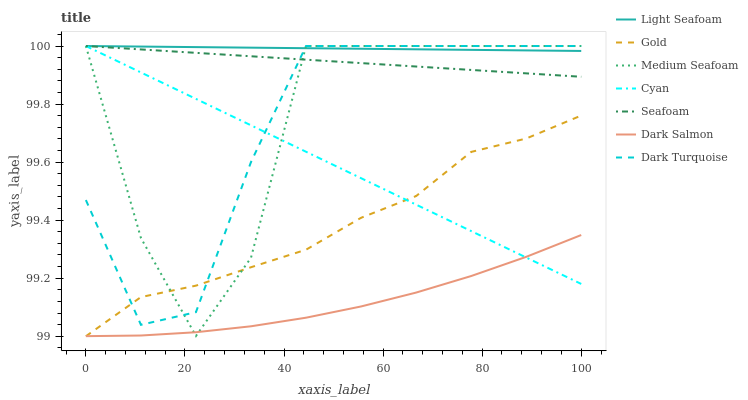Does Dark Salmon have the minimum area under the curve?
Answer yes or no. Yes. Does Light Seafoam have the maximum area under the curve?
Answer yes or no. Yes. Does Dark Turquoise have the minimum area under the curve?
Answer yes or no. No. Does Dark Turquoise have the maximum area under the curve?
Answer yes or no. No. Is Light Seafoam the smoothest?
Answer yes or no. Yes. Is Medium Seafoam the roughest?
Answer yes or no. Yes. Is Dark Turquoise the smoothest?
Answer yes or no. No. Is Dark Turquoise the roughest?
Answer yes or no. No. Does Dark Turquoise have the lowest value?
Answer yes or no. No. Does Medium Seafoam have the highest value?
Answer yes or no. Yes. Does Dark Salmon have the highest value?
Answer yes or no. No. Is Dark Salmon less than Dark Turquoise?
Answer yes or no. Yes. Is Dark Turquoise greater than Dark Salmon?
Answer yes or no. Yes. Does Seafoam intersect Cyan?
Answer yes or no. Yes. Is Seafoam less than Cyan?
Answer yes or no. No. Is Seafoam greater than Cyan?
Answer yes or no. No. Does Dark Salmon intersect Dark Turquoise?
Answer yes or no. No. 